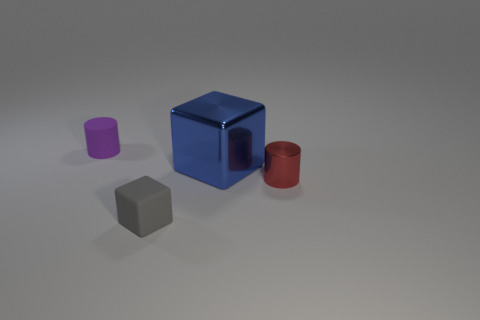There is a thing that is both behind the red cylinder and on the right side of the small gray cube; what shape is it? The object that is positioned behind the red cylinder and to the right side of the small gray cube is a cube as well. It's the larger blue one, showing how objects can relate to each other spatially. 